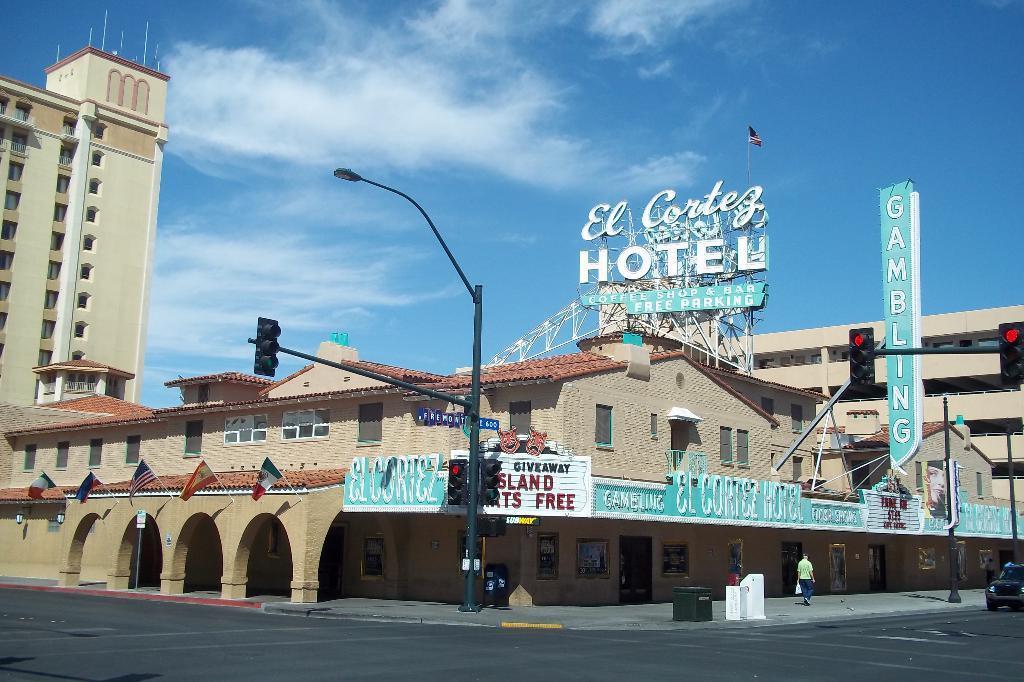Can you describe this image briefly? We can see lights and traffic signals on poles and there is a person walking and holding an object. We can see car on the road, box, boards, flags with sticks, buildings, rods and hoarding. In the background we can see sky with clouds. 